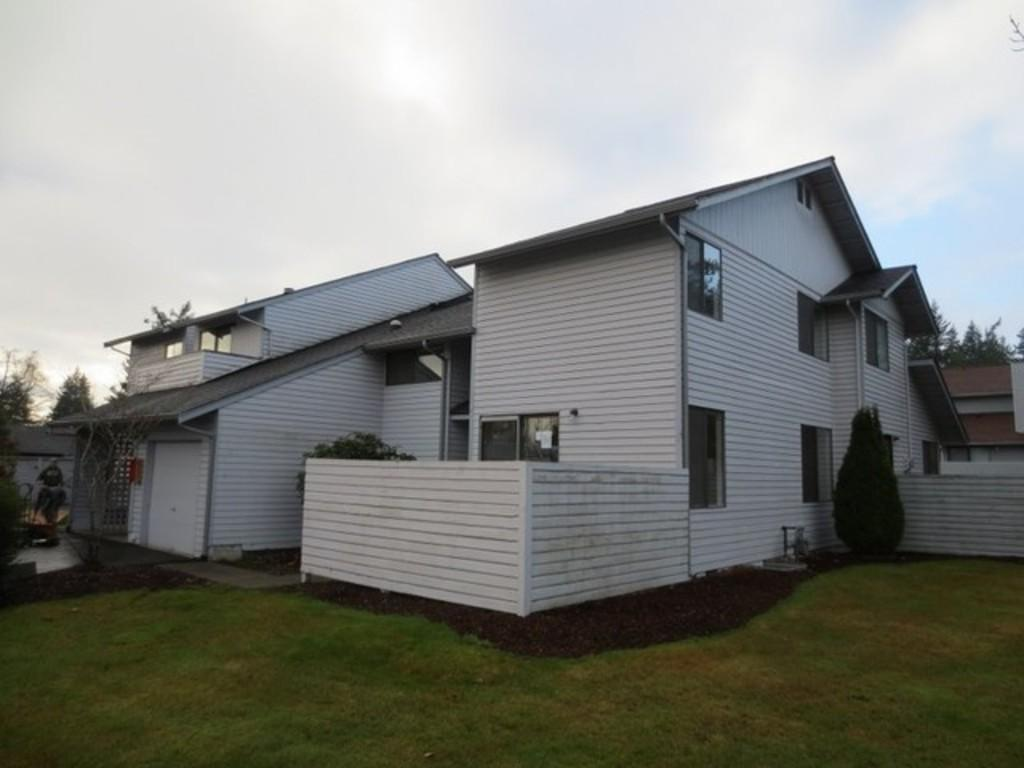What type of structure is present in the image? There is a building with windows in the image. What can be seen near the building? There are trees near the building. What is on the ground in the image? There is grass on the ground. What is visible in the background of the image? The sky is visible in the background. How many buttons can be seen on the building in the image? There are no buttons visible on the building in the image. Is the area around the building quiet or noisy? The image does not provide any information about the noise level in the area, so it cannot be determined. 